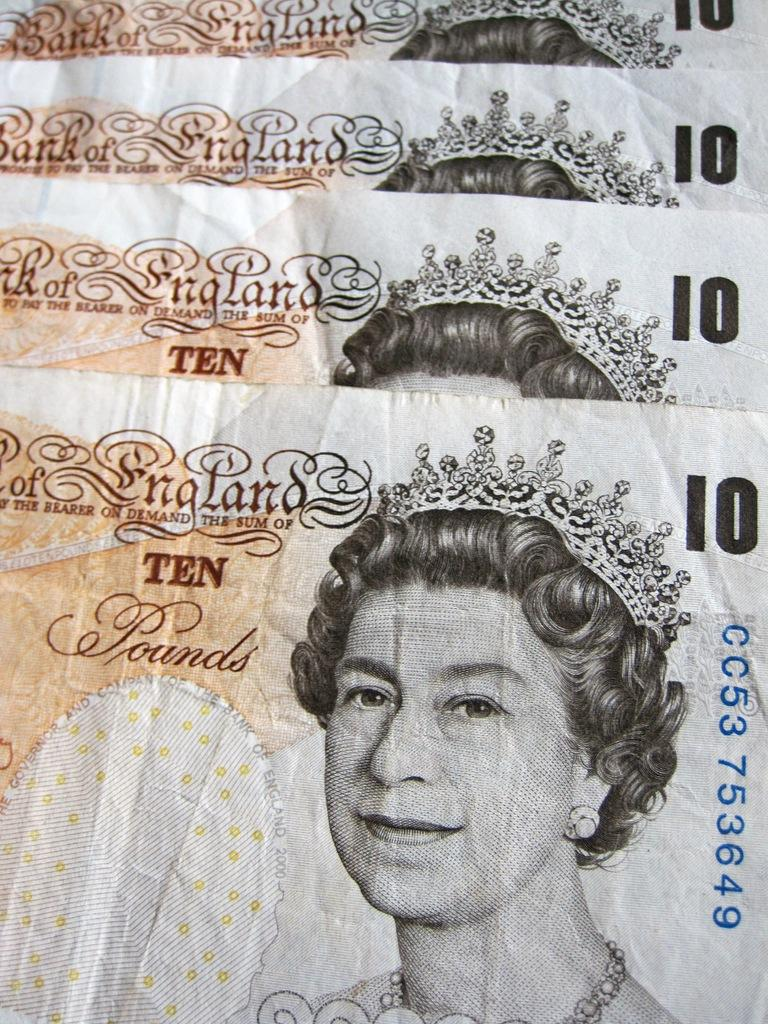How many currency notes are visible in the image? There are four currency notes in the image. What can be seen on the currency notes? The currency notes have depictions of women. Are there any words or numbers on the currency notes? Yes, there is writing on the currency notes. Can you see a tail on any of the depicted women on the currency notes? There is no tail visible on any of the depicted women on the currency notes. 